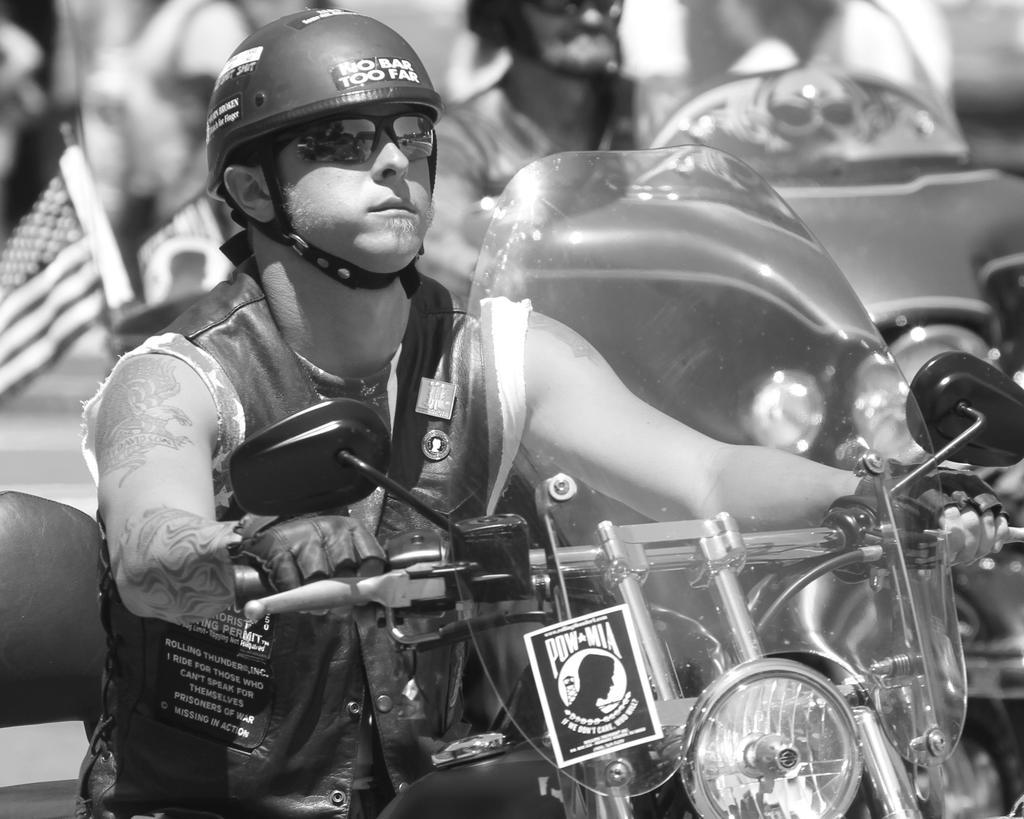Could you give a brief overview of what you see in this image? In the middle of the image few persons are riding motorcycles. 